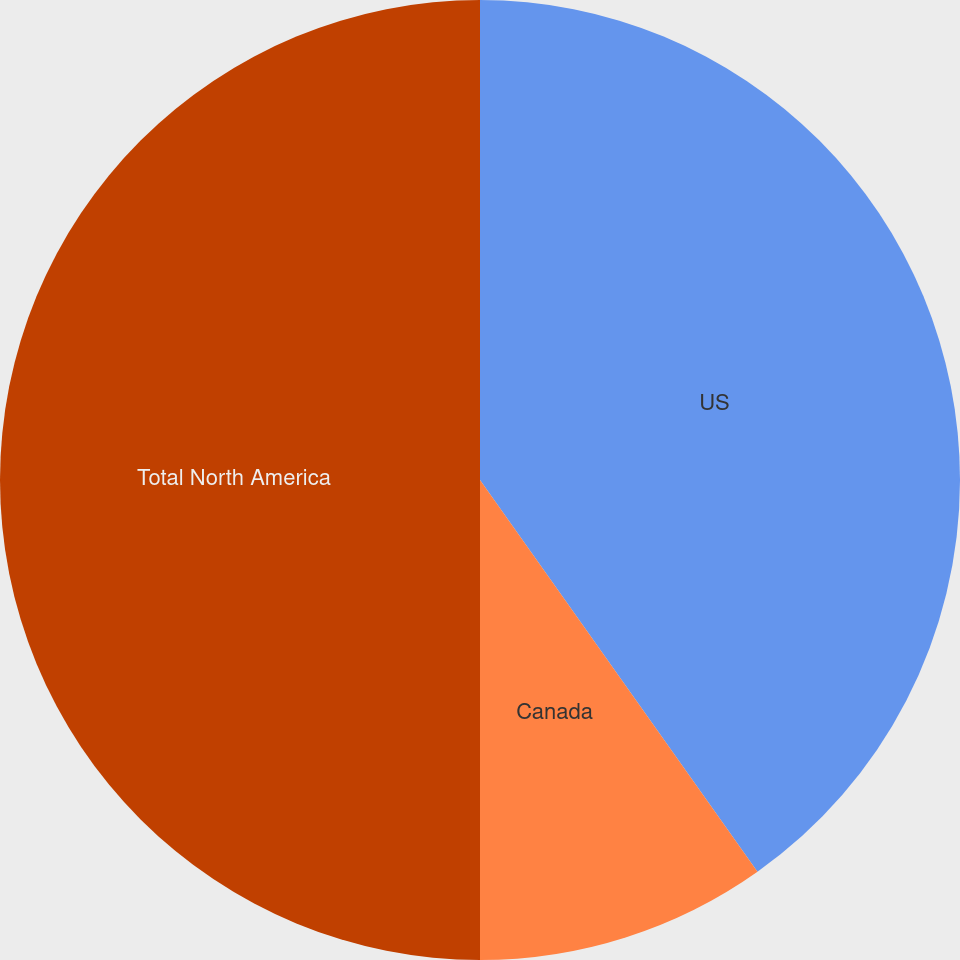Convert chart to OTSL. <chart><loc_0><loc_0><loc_500><loc_500><pie_chart><fcel>US<fcel>Canada<fcel>Total North America<nl><fcel>40.19%<fcel>9.81%<fcel>50.0%<nl></chart> 